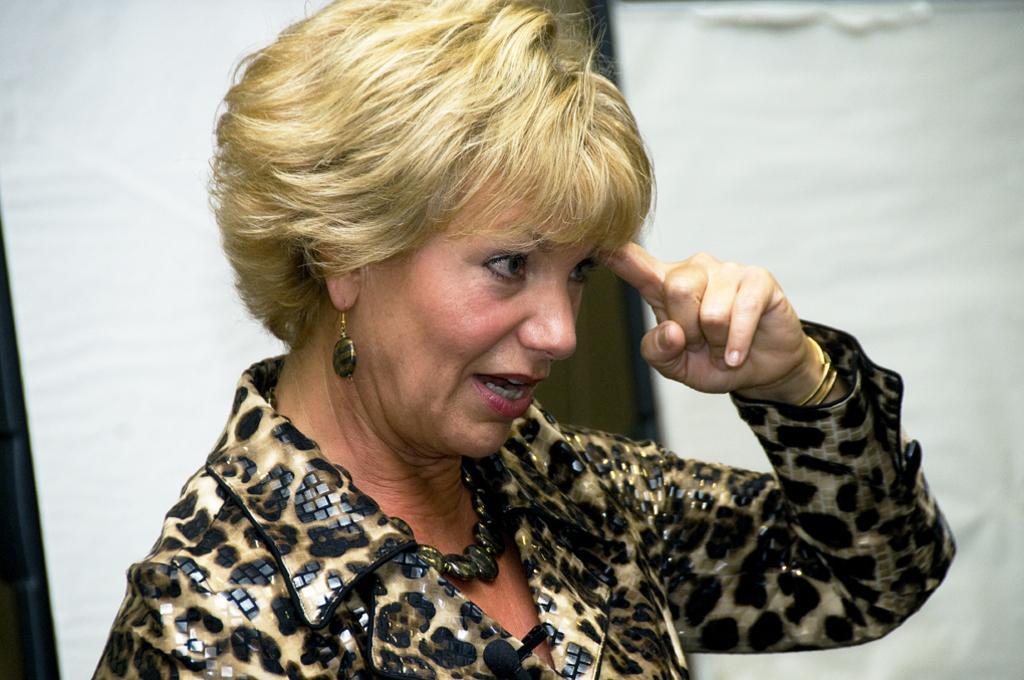How would you summarize this image in a sentence or two? In the image there is a woman she is speaking something, she is wearing a designer dress and the background of the woman is blur. 